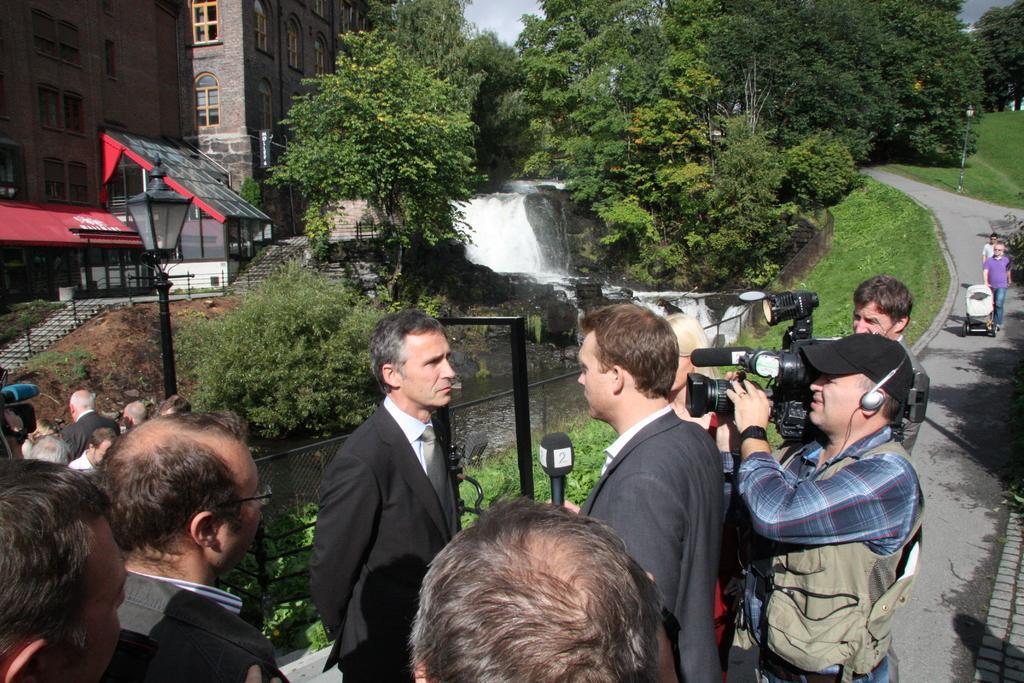Could you give a brief overview of what you see in this image? In this picture I can see group of people are standing. This person is holding a microphone and this person is holding video camera. In the background I can see water, the grass, trees, the sky and buildings. Here I can see a road on which some people are walking. Here I can see street light and some other objects over here. 